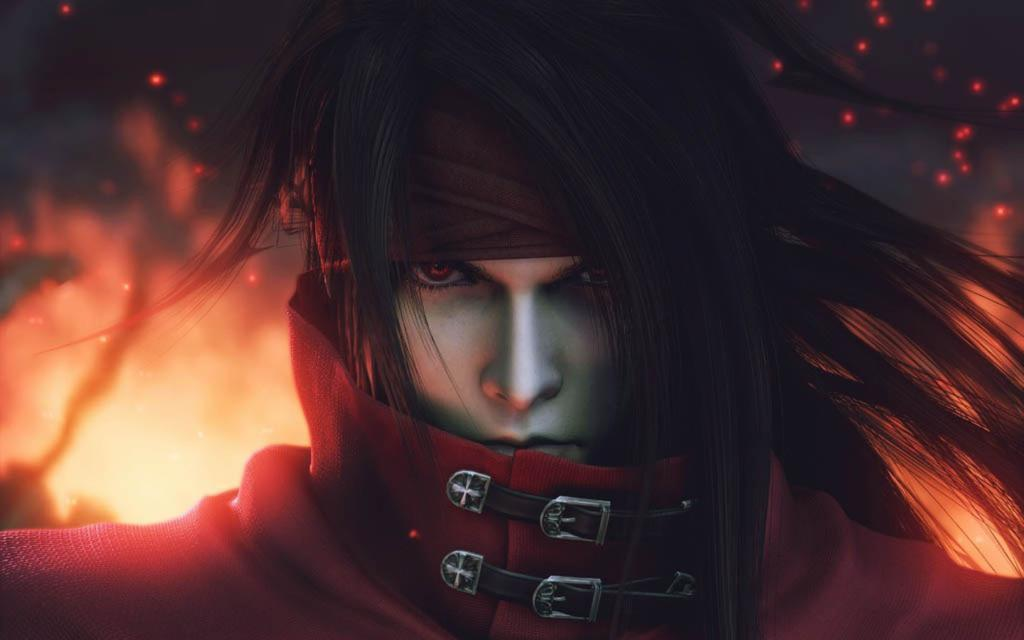What type of image is being described? The image is an animated picture. Can you describe the person in the image? There is a person in the image. What can be seen in the background of the image? There are sparks and flames in the background of the image. What type of humor is being displayed by the class in the image? There is no class or any indication of humor present in the image. 